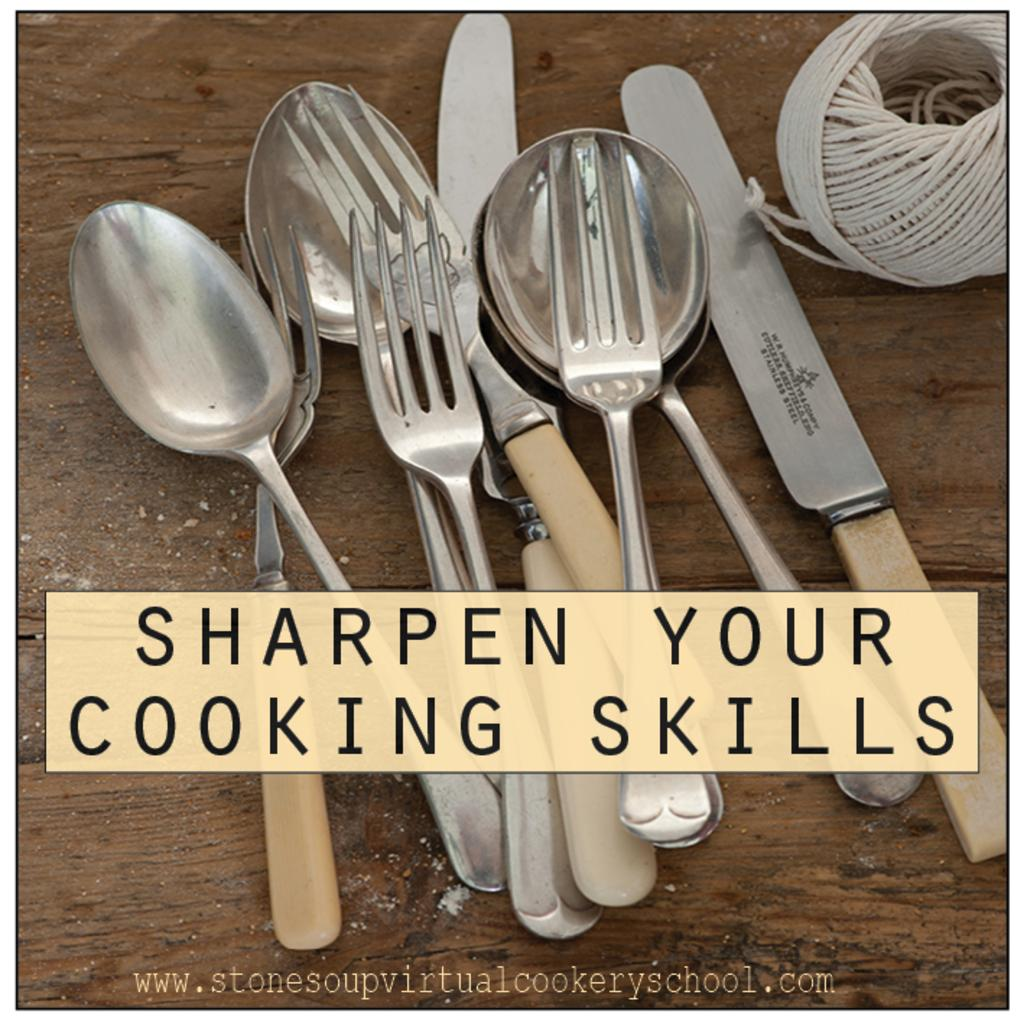What types of utensils are on the table in the image? There are spoons, forks, and knives on the table in the image. What might be used for cutting, eating, and serving food in the image? The knives, forks, and spoons on the table can be used for cutting, eating, and serving food. What can be seen written on the photograph? Unfortunately, the specific content of what is written on the photograph cannot be determined from the provided facts. How many horses are pulling the carriage in the image? There is no carriage present in the image, so it is not possible to determine the number of horses pulling it. 